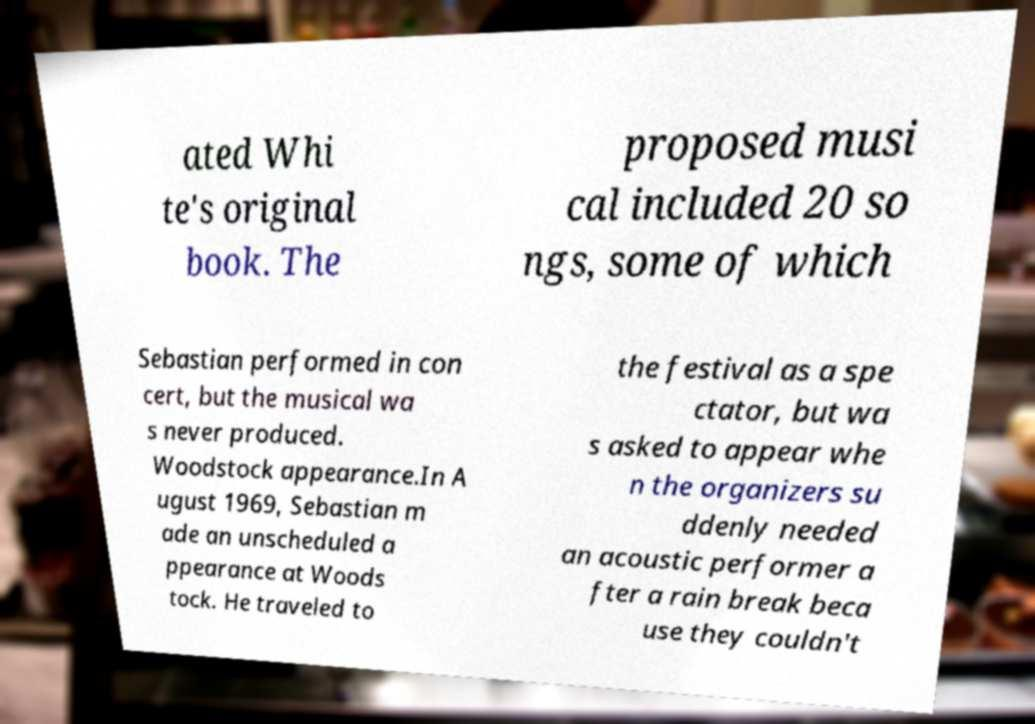Could you extract and type out the text from this image? ated Whi te's original book. The proposed musi cal included 20 so ngs, some of which Sebastian performed in con cert, but the musical wa s never produced. Woodstock appearance.In A ugust 1969, Sebastian m ade an unscheduled a ppearance at Woods tock. He traveled to the festival as a spe ctator, but wa s asked to appear whe n the organizers su ddenly needed an acoustic performer a fter a rain break beca use they couldn't 